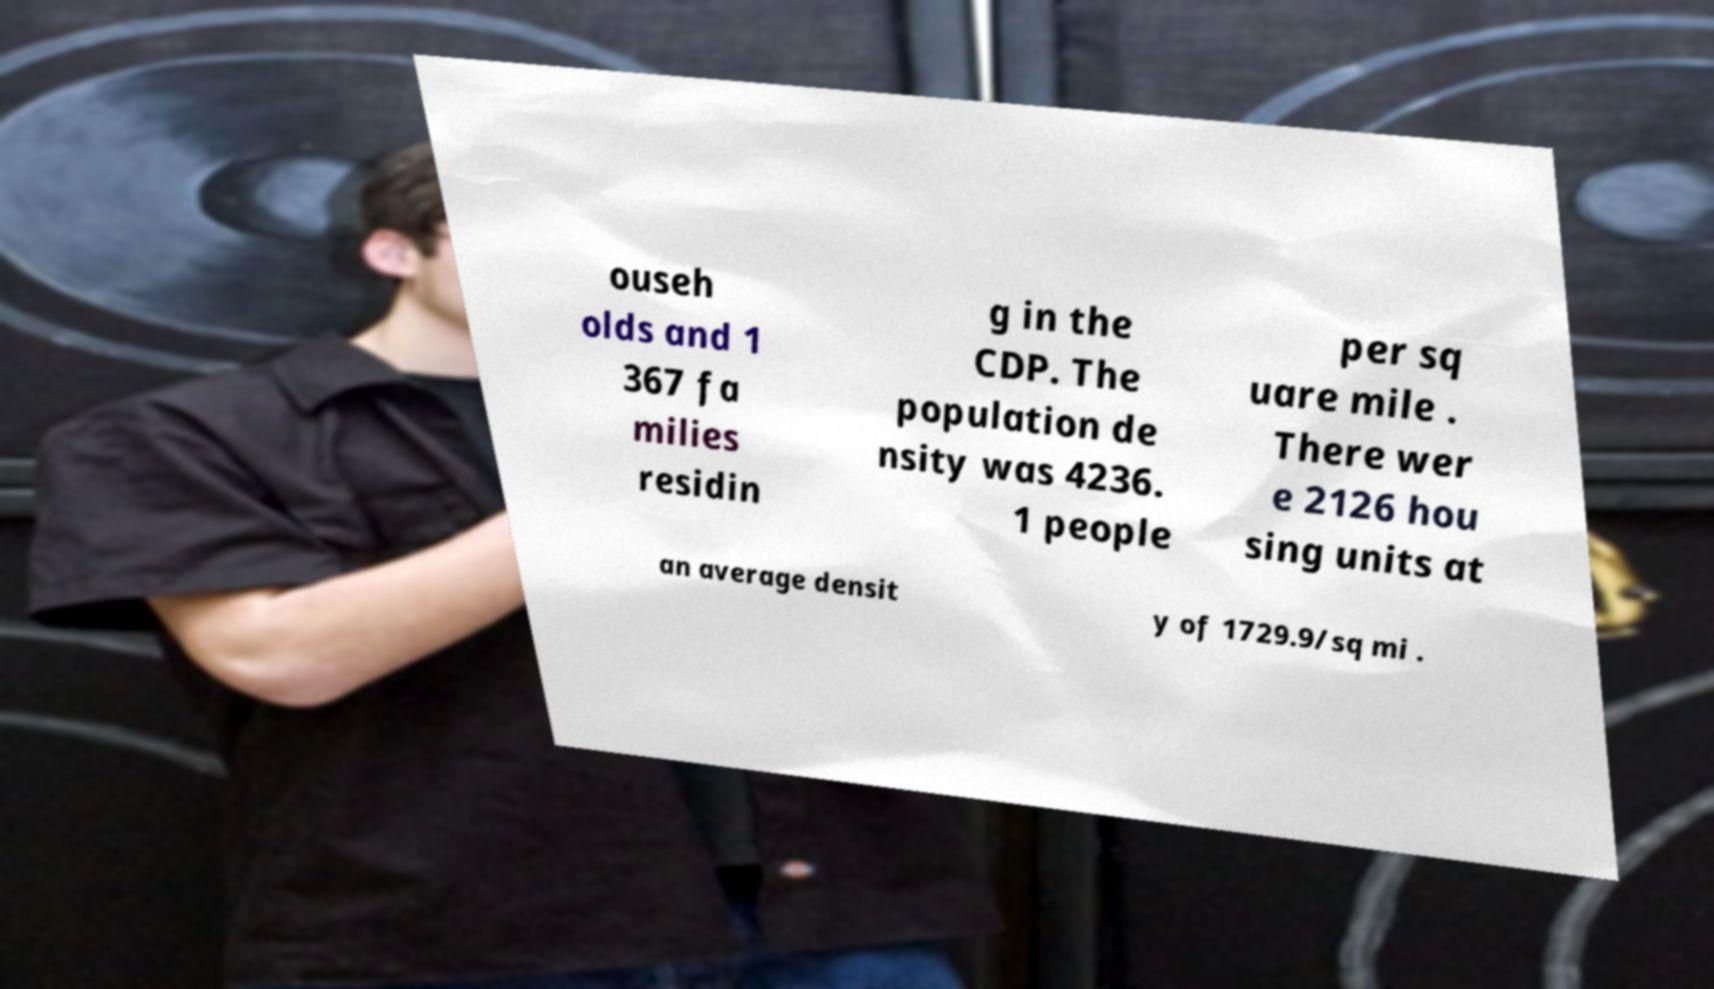Could you extract and type out the text from this image? ouseh olds and 1 367 fa milies residin g in the CDP. The population de nsity was 4236. 1 people per sq uare mile . There wer e 2126 hou sing units at an average densit y of 1729.9/sq mi . 